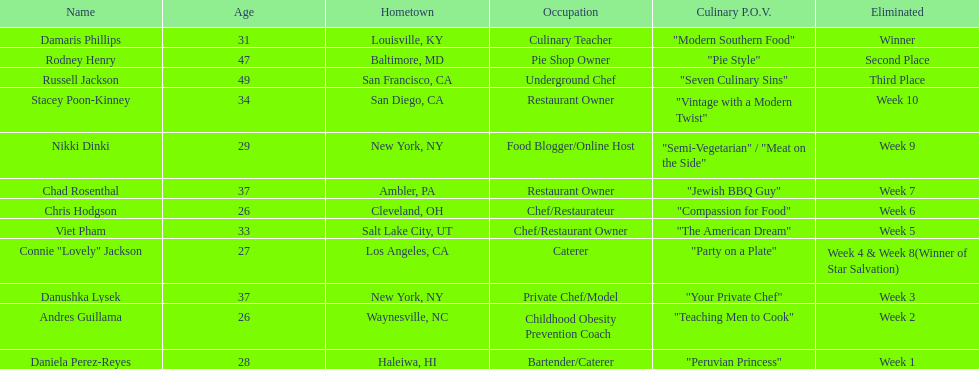How many contestants were below 30 years old? 5. 